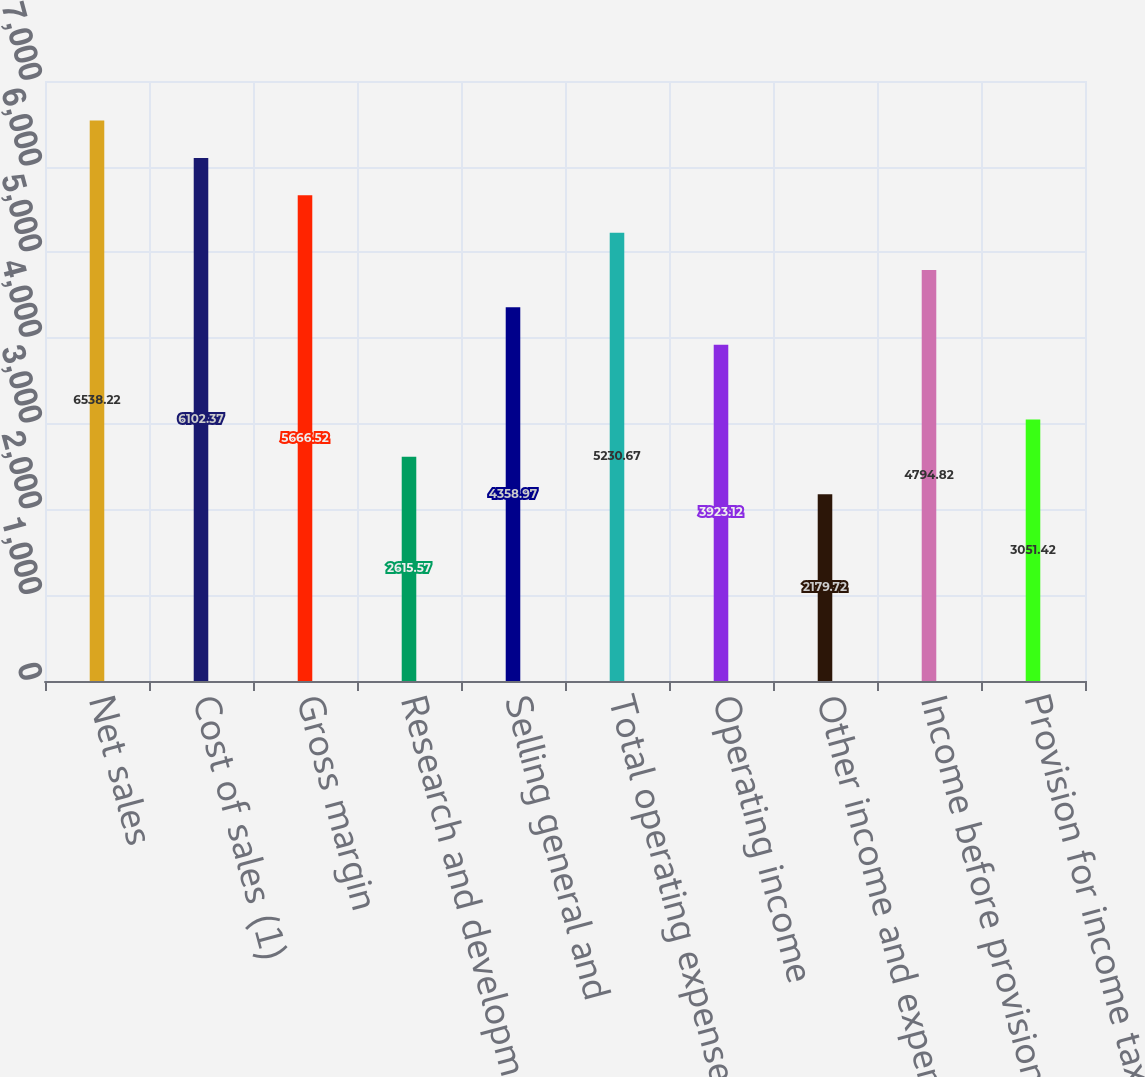Convert chart to OTSL. <chart><loc_0><loc_0><loc_500><loc_500><bar_chart><fcel>Net sales<fcel>Cost of sales (1)<fcel>Gross margin<fcel>Research and development (1)<fcel>Selling general and<fcel>Total operating expenses<fcel>Operating income<fcel>Other income and expense<fcel>Income before provision for<fcel>Provision for income taxes<nl><fcel>6538.22<fcel>6102.37<fcel>5666.52<fcel>2615.57<fcel>4358.97<fcel>5230.67<fcel>3923.12<fcel>2179.72<fcel>4794.82<fcel>3051.42<nl></chart> 